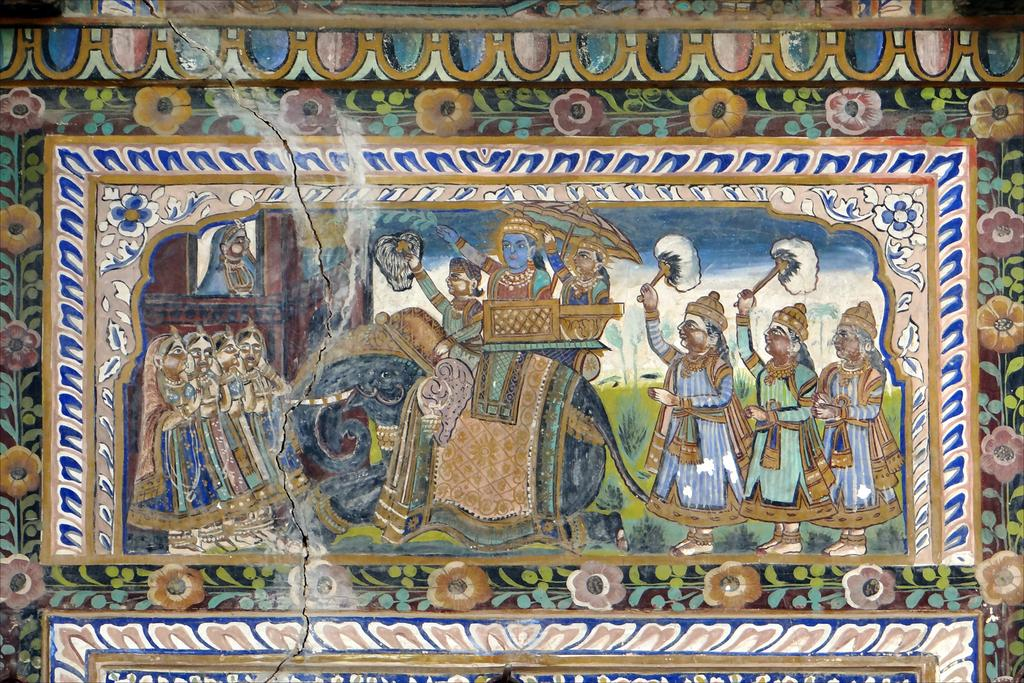What type of artwork is depicted on the wall in the image? There are paintings of people and an elephant in the image. Are there any other paintings visible in the image? Yes, there are other paintings in the image. Where are the paintings located in the image? The paintings are on a wall. Can you see any goldfish swimming in the paintings? There are no goldfish present in the paintings; they depict people and an elephant. How comfortable are the people in the paintings? The paintings do not convey a sense of comfort or discomfort; they are static images of people and an elephant. 